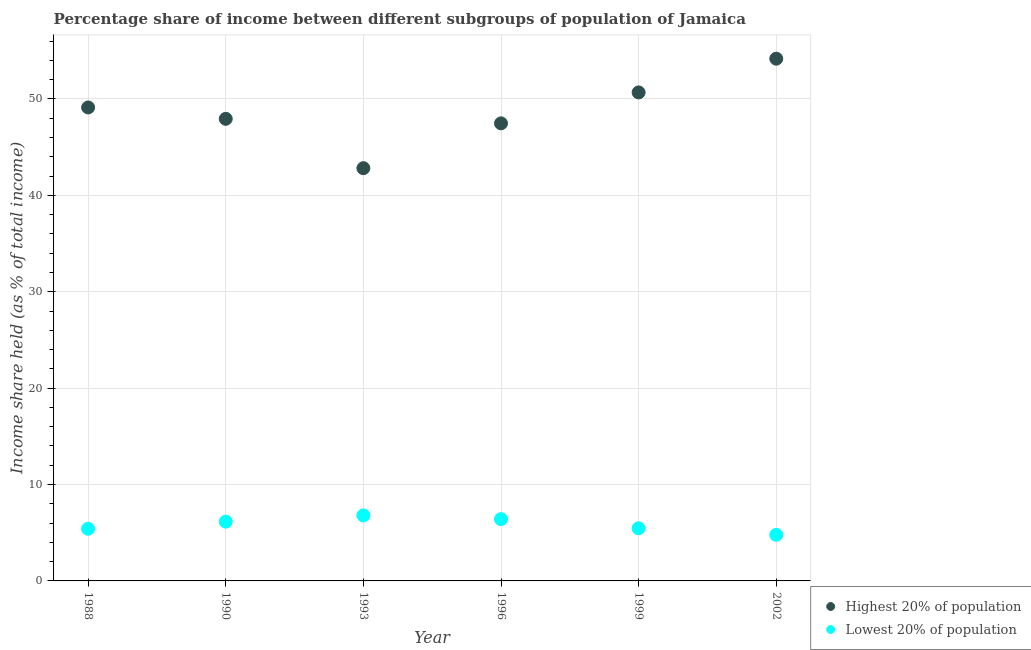How many different coloured dotlines are there?
Offer a terse response. 2. What is the income share held by lowest 20% of the population in 1988?
Your answer should be very brief. 5.41. Across all years, what is the maximum income share held by lowest 20% of the population?
Your answer should be very brief. 6.8. Across all years, what is the minimum income share held by lowest 20% of the population?
Your answer should be very brief. 4.78. In which year was the income share held by highest 20% of the population minimum?
Your answer should be very brief. 1993. What is the total income share held by highest 20% of the population in the graph?
Ensure brevity in your answer.  292.21. What is the difference between the income share held by lowest 20% of the population in 1990 and that in 2002?
Your response must be concise. 1.37. What is the difference between the income share held by highest 20% of the population in 2002 and the income share held by lowest 20% of the population in 1996?
Ensure brevity in your answer.  47.77. What is the average income share held by highest 20% of the population per year?
Keep it short and to the point. 48.7. In the year 1996, what is the difference between the income share held by lowest 20% of the population and income share held by highest 20% of the population?
Your answer should be very brief. -41.06. What is the ratio of the income share held by lowest 20% of the population in 1999 to that in 2002?
Make the answer very short. 1.14. Is the income share held by highest 20% of the population in 1988 less than that in 1999?
Your response must be concise. Yes. Is the difference between the income share held by highest 20% of the population in 1990 and 1999 greater than the difference between the income share held by lowest 20% of the population in 1990 and 1999?
Provide a short and direct response. No. What is the difference between the highest and the second highest income share held by lowest 20% of the population?
Provide a short and direct response. 0.39. What is the difference between the highest and the lowest income share held by highest 20% of the population?
Keep it short and to the point. 11.36. Does the income share held by lowest 20% of the population monotonically increase over the years?
Ensure brevity in your answer.  No. Is the income share held by highest 20% of the population strictly greater than the income share held by lowest 20% of the population over the years?
Your answer should be very brief. Yes. Is the income share held by lowest 20% of the population strictly less than the income share held by highest 20% of the population over the years?
Your answer should be compact. Yes. How many dotlines are there?
Your answer should be compact. 2. Are the values on the major ticks of Y-axis written in scientific E-notation?
Keep it short and to the point. No. Does the graph contain any zero values?
Provide a short and direct response. No. Does the graph contain grids?
Provide a short and direct response. Yes. How are the legend labels stacked?
Provide a succinct answer. Vertical. What is the title of the graph?
Your answer should be compact. Percentage share of income between different subgroups of population of Jamaica. What is the label or title of the X-axis?
Offer a very short reply. Year. What is the label or title of the Y-axis?
Keep it short and to the point. Income share held (as % of total income). What is the Income share held (as % of total income) of Highest 20% of population in 1988?
Your answer should be compact. 49.12. What is the Income share held (as % of total income) of Lowest 20% of population in 1988?
Make the answer very short. 5.41. What is the Income share held (as % of total income) in Highest 20% of population in 1990?
Offer a very short reply. 47.94. What is the Income share held (as % of total income) in Lowest 20% of population in 1990?
Offer a very short reply. 6.15. What is the Income share held (as % of total income) of Highest 20% of population in 1993?
Provide a short and direct response. 42.82. What is the Income share held (as % of total income) in Highest 20% of population in 1996?
Make the answer very short. 47.47. What is the Income share held (as % of total income) in Lowest 20% of population in 1996?
Offer a terse response. 6.41. What is the Income share held (as % of total income) of Highest 20% of population in 1999?
Give a very brief answer. 50.68. What is the Income share held (as % of total income) of Lowest 20% of population in 1999?
Offer a very short reply. 5.46. What is the Income share held (as % of total income) of Highest 20% of population in 2002?
Your answer should be compact. 54.18. What is the Income share held (as % of total income) in Lowest 20% of population in 2002?
Offer a very short reply. 4.78. Across all years, what is the maximum Income share held (as % of total income) in Highest 20% of population?
Your answer should be very brief. 54.18. Across all years, what is the maximum Income share held (as % of total income) of Lowest 20% of population?
Your answer should be compact. 6.8. Across all years, what is the minimum Income share held (as % of total income) of Highest 20% of population?
Offer a terse response. 42.82. Across all years, what is the minimum Income share held (as % of total income) of Lowest 20% of population?
Make the answer very short. 4.78. What is the total Income share held (as % of total income) of Highest 20% of population in the graph?
Provide a short and direct response. 292.21. What is the total Income share held (as % of total income) of Lowest 20% of population in the graph?
Give a very brief answer. 35.01. What is the difference between the Income share held (as % of total income) in Highest 20% of population in 1988 and that in 1990?
Your response must be concise. 1.18. What is the difference between the Income share held (as % of total income) in Lowest 20% of population in 1988 and that in 1990?
Your answer should be very brief. -0.74. What is the difference between the Income share held (as % of total income) in Lowest 20% of population in 1988 and that in 1993?
Keep it short and to the point. -1.39. What is the difference between the Income share held (as % of total income) of Highest 20% of population in 1988 and that in 1996?
Provide a succinct answer. 1.65. What is the difference between the Income share held (as % of total income) of Lowest 20% of population in 1988 and that in 1996?
Give a very brief answer. -1. What is the difference between the Income share held (as % of total income) in Highest 20% of population in 1988 and that in 1999?
Make the answer very short. -1.56. What is the difference between the Income share held (as % of total income) in Highest 20% of population in 1988 and that in 2002?
Offer a terse response. -5.06. What is the difference between the Income share held (as % of total income) of Lowest 20% of population in 1988 and that in 2002?
Offer a very short reply. 0.63. What is the difference between the Income share held (as % of total income) in Highest 20% of population in 1990 and that in 1993?
Keep it short and to the point. 5.12. What is the difference between the Income share held (as % of total income) in Lowest 20% of population in 1990 and that in 1993?
Provide a succinct answer. -0.65. What is the difference between the Income share held (as % of total income) of Highest 20% of population in 1990 and that in 1996?
Give a very brief answer. 0.47. What is the difference between the Income share held (as % of total income) of Lowest 20% of population in 1990 and that in 1996?
Your response must be concise. -0.26. What is the difference between the Income share held (as % of total income) of Highest 20% of population in 1990 and that in 1999?
Your answer should be very brief. -2.74. What is the difference between the Income share held (as % of total income) of Lowest 20% of population in 1990 and that in 1999?
Your answer should be very brief. 0.69. What is the difference between the Income share held (as % of total income) of Highest 20% of population in 1990 and that in 2002?
Provide a succinct answer. -6.24. What is the difference between the Income share held (as % of total income) in Lowest 20% of population in 1990 and that in 2002?
Give a very brief answer. 1.37. What is the difference between the Income share held (as % of total income) of Highest 20% of population in 1993 and that in 1996?
Offer a terse response. -4.65. What is the difference between the Income share held (as % of total income) in Lowest 20% of population in 1993 and that in 1996?
Your answer should be compact. 0.39. What is the difference between the Income share held (as % of total income) of Highest 20% of population in 1993 and that in 1999?
Your answer should be very brief. -7.86. What is the difference between the Income share held (as % of total income) in Lowest 20% of population in 1993 and that in 1999?
Provide a short and direct response. 1.34. What is the difference between the Income share held (as % of total income) of Highest 20% of population in 1993 and that in 2002?
Offer a very short reply. -11.36. What is the difference between the Income share held (as % of total income) of Lowest 20% of population in 1993 and that in 2002?
Ensure brevity in your answer.  2.02. What is the difference between the Income share held (as % of total income) in Highest 20% of population in 1996 and that in 1999?
Ensure brevity in your answer.  -3.21. What is the difference between the Income share held (as % of total income) in Lowest 20% of population in 1996 and that in 1999?
Give a very brief answer. 0.95. What is the difference between the Income share held (as % of total income) in Highest 20% of population in 1996 and that in 2002?
Your answer should be compact. -6.71. What is the difference between the Income share held (as % of total income) of Lowest 20% of population in 1996 and that in 2002?
Your answer should be compact. 1.63. What is the difference between the Income share held (as % of total income) of Lowest 20% of population in 1999 and that in 2002?
Keep it short and to the point. 0.68. What is the difference between the Income share held (as % of total income) in Highest 20% of population in 1988 and the Income share held (as % of total income) in Lowest 20% of population in 1990?
Ensure brevity in your answer.  42.97. What is the difference between the Income share held (as % of total income) in Highest 20% of population in 1988 and the Income share held (as % of total income) in Lowest 20% of population in 1993?
Give a very brief answer. 42.32. What is the difference between the Income share held (as % of total income) in Highest 20% of population in 1988 and the Income share held (as % of total income) in Lowest 20% of population in 1996?
Ensure brevity in your answer.  42.71. What is the difference between the Income share held (as % of total income) in Highest 20% of population in 1988 and the Income share held (as % of total income) in Lowest 20% of population in 1999?
Offer a very short reply. 43.66. What is the difference between the Income share held (as % of total income) of Highest 20% of population in 1988 and the Income share held (as % of total income) of Lowest 20% of population in 2002?
Provide a short and direct response. 44.34. What is the difference between the Income share held (as % of total income) in Highest 20% of population in 1990 and the Income share held (as % of total income) in Lowest 20% of population in 1993?
Offer a terse response. 41.14. What is the difference between the Income share held (as % of total income) in Highest 20% of population in 1990 and the Income share held (as % of total income) in Lowest 20% of population in 1996?
Your response must be concise. 41.53. What is the difference between the Income share held (as % of total income) in Highest 20% of population in 1990 and the Income share held (as % of total income) in Lowest 20% of population in 1999?
Your answer should be compact. 42.48. What is the difference between the Income share held (as % of total income) in Highest 20% of population in 1990 and the Income share held (as % of total income) in Lowest 20% of population in 2002?
Ensure brevity in your answer.  43.16. What is the difference between the Income share held (as % of total income) in Highest 20% of population in 1993 and the Income share held (as % of total income) in Lowest 20% of population in 1996?
Offer a very short reply. 36.41. What is the difference between the Income share held (as % of total income) of Highest 20% of population in 1993 and the Income share held (as % of total income) of Lowest 20% of population in 1999?
Your answer should be compact. 37.36. What is the difference between the Income share held (as % of total income) in Highest 20% of population in 1993 and the Income share held (as % of total income) in Lowest 20% of population in 2002?
Your response must be concise. 38.04. What is the difference between the Income share held (as % of total income) of Highest 20% of population in 1996 and the Income share held (as % of total income) of Lowest 20% of population in 1999?
Offer a terse response. 42.01. What is the difference between the Income share held (as % of total income) in Highest 20% of population in 1996 and the Income share held (as % of total income) in Lowest 20% of population in 2002?
Offer a very short reply. 42.69. What is the difference between the Income share held (as % of total income) in Highest 20% of population in 1999 and the Income share held (as % of total income) in Lowest 20% of population in 2002?
Provide a succinct answer. 45.9. What is the average Income share held (as % of total income) of Highest 20% of population per year?
Your answer should be compact. 48.7. What is the average Income share held (as % of total income) of Lowest 20% of population per year?
Your answer should be very brief. 5.83. In the year 1988, what is the difference between the Income share held (as % of total income) of Highest 20% of population and Income share held (as % of total income) of Lowest 20% of population?
Offer a very short reply. 43.71. In the year 1990, what is the difference between the Income share held (as % of total income) in Highest 20% of population and Income share held (as % of total income) in Lowest 20% of population?
Ensure brevity in your answer.  41.79. In the year 1993, what is the difference between the Income share held (as % of total income) in Highest 20% of population and Income share held (as % of total income) in Lowest 20% of population?
Make the answer very short. 36.02. In the year 1996, what is the difference between the Income share held (as % of total income) of Highest 20% of population and Income share held (as % of total income) of Lowest 20% of population?
Ensure brevity in your answer.  41.06. In the year 1999, what is the difference between the Income share held (as % of total income) of Highest 20% of population and Income share held (as % of total income) of Lowest 20% of population?
Your answer should be very brief. 45.22. In the year 2002, what is the difference between the Income share held (as % of total income) in Highest 20% of population and Income share held (as % of total income) in Lowest 20% of population?
Ensure brevity in your answer.  49.4. What is the ratio of the Income share held (as % of total income) in Highest 20% of population in 1988 to that in 1990?
Your answer should be compact. 1.02. What is the ratio of the Income share held (as % of total income) of Lowest 20% of population in 1988 to that in 1990?
Provide a succinct answer. 0.88. What is the ratio of the Income share held (as % of total income) of Highest 20% of population in 1988 to that in 1993?
Offer a very short reply. 1.15. What is the ratio of the Income share held (as % of total income) in Lowest 20% of population in 1988 to that in 1993?
Provide a succinct answer. 0.8. What is the ratio of the Income share held (as % of total income) of Highest 20% of population in 1988 to that in 1996?
Keep it short and to the point. 1.03. What is the ratio of the Income share held (as % of total income) of Lowest 20% of population in 1988 to that in 1996?
Ensure brevity in your answer.  0.84. What is the ratio of the Income share held (as % of total income) in Highest 20% of population in 1988 to that in 1999?
Keep it short and to the point. 0.97. What is the ratio of the Income share held (as % of total income) in Highest 20% of population in 1988 to that in 2002?
Offer a terse response. 0.91. What is the ratio of the Income share held (as % of total income) of Lowest 20% of population in 1988 to that in 2002?
Your answer should be compact. 1.13. What is the ratio of the Income share held (as % of total income) in Highest 20% of population in 1990 to that in 1993?
Give a very brief answer. 1.12. What is the ratio of the Income share held (as % of total income) in Lowest 20% of population in 1990 to that in 1993?
Give a very brief answer. 0.9. What is the ratio of the Income share held (as % of total income) in Highest 20% of population in 1990 to that in 1996?
Your answer should be compact. 1.01. What is the ratio of the Income share held (as % of total income) in Lowest 20% of population in 1990 to that in 1996?
Provide a short and direct response. 0.96. What is the ratio of the Income share held (as % of total income) of Highest 20% of population in 1990 to that in 1999?
Your answer should be very brief. 0.95. What is the ratio of the Income share held (as % of total income) of Lowest 20% of population in 1990 to that in 1999?
Ensure brevity in your answer.  1.13. What is the ratio of the Income share held (as % of total income) in Highest 20% of population in 1990 to that in 2002?
Offer a terse response. 0.88. What is the ratio of the Income share held (as % of total income) of Lowest 20% of population in 1990 to that in 2002?
Your response must be concise. 1.29. What is the ratio of the Income share held (as % of total income) of Highest 20% of population in 1993 to that in 1996?
Ensure brevity in your answer.  0.9. What is the ratio of the Income share held (as % of total income) in Lowest 20% of population in 1993 to that in 1996?
Give a very brief answer. 1.06. What is the ratio of the Income share held (as % of total income) of Highest 20% of population in 1993 to that in 1999?
Give a very brief answer. 0.84. What is the ratio of the Income share held (as % of total income) of Lowest 20% of population in 1993 to that in 1999?
Offer a terse response. 1.25. What is the ratio of the Income share held (as % of total income) in Highest 20% of population in 1993 to that in 2002?
Give a very brief answer. 0.79. What is the ratio of the Income share held (as % of total income) in Lowest 20% of population in 1993 to that in 2002?
Provide a short and direct response. 1.42. What is the ratio of the Income share held (as % of total income) of Highest 20% of population in 1996 to that in 1999?
Your answer should be very brief. 0.94. What is the ratio of the Income share held (as % of total income) in Lowest 20% of population in 1996 to that in 1999?
Your response must be concise. 1.17. What is the ratio of the Income share held (as % of total income) of Highest 20% of population in 1996 to that in 2002?
Your response must be concise. 0.88. What is the ratio of the Income share held (as % of total income) of Lowest 20% of population in 1996 to that in 2002?
Keep it short and to the point. 1.34. What is the ratio of the Income share held (as % of total income) in Highest 20% of population in 1999 to that in 2002?
Your answer should be very brief. 0.94. What is the ratio of the Income share held (as % of total income) of Lowest 20% of population in 1999 to that in 2002?
Ensure brevity in your answer.  1.14. What is the difference between the highest and the second highest Income share held (as % of total income) in Highest 20% of population?
Your answer should be compact. 3.5. What is the difference between the highest and the second highest Income share held (as % of total income) of Lowest 20% of population?
Offer a very short reply. 0.39. What is the difference between the highest and the lowest Income share held (as % of total income) of Highest 20% of population?
Make the answer very short. 11.36. What is the difference between the highest and the lowest Income share held (as % of total income) of Lowest 20% of population?
Your response must be concise. 2.02. 